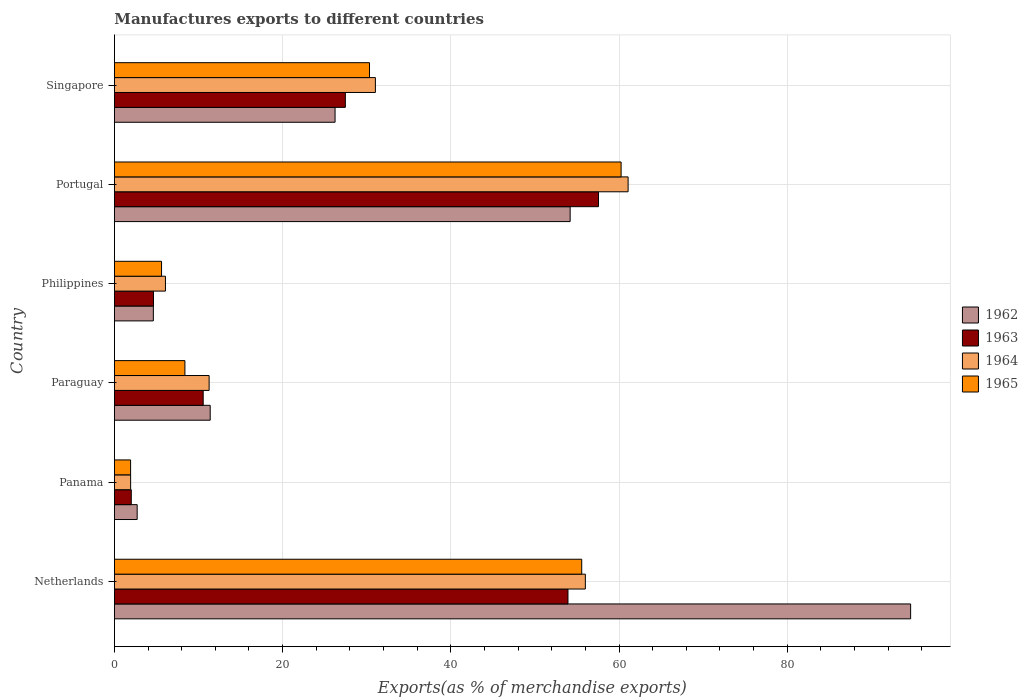Are the number of bars per tick equal to the number of legend labels?
Provide a short and direct response. Yes. How many bars are there on the 6th tick from the bottom?
Ensure brevity in your answer.  4. What is the label of the 6th group of bars from the top?
Keep it short and to the point. Netherlands. What is the percentage of exports to different countries in 1963 in Philippines?
Your answer should be compact. 4.64. Across all countries, what is the maximum percentage of exports to different countries in 1963?
Keep it short and to the point. 57.56. Across all countries, what is the minimum percentage of exports to different countries in 1963?
Your answer should be very brief. 2. In which country was the percentage of exports to different countries in 1964 maximum?
Your response must be concise. Portugal. In which country was the percentage of exports to different countries in 1963 minimum?
Keep it short and to the point. Panama. What is the total percentage of exports to different countries in 1962 in the graph?
Offer a very short reply. 193.83. What is the difference between the percentage of exports to different countries in 1962 in Panama and that in Singapore?
Your answer should be compact. -23.53. What is the difference between the percentage of exports to different countries in 1962 in Panama and the percentage of exports to different countries in 1963 in Singapore?
Make the answer very short. -24.76. What is the average percentage of exports to different countries in 1964 per country?
Keep it short and to the point. 27.89. What is the difference between the percentage of exports to different countries in 1962 and percentage of exports to different countries in 1963 in Paraguay?
Offer a terse response. 0.83. What is the ratio of the percentage of exports to different countries in 1962 in Netherlands to that in Paraguay?
Provide a short and direct response. 8.31. Is the percentage of exports to different countries in 1965 in Panama less than that in Portugal?
Give a very brief answer. Yes. What is the difference between the highest and the second highest percentage of exports to different countries in 1965?
Your response must be concise. 4.68. What is the difference between the highest and the lowest percentage of exports to different countries in 1963?
Make the answer very short. 55.56. What does the 3rd bar from the top in Philippines represents?
Ensure brevity in your answer.  1963. What does the 2nd bar from the bottom in Philippines represents?
Offer a very short reply. 1963. How many bars are there?
Offer a terse response. 24. Where does the legend appear in the graph?
Your answer should be compact. Center right. How many legend labels are there?
Offer a terse response. 4. How are the legend labels stacked?
Ensure brevity in your answer.  Vertical. What is the title of the graph?
Provide a succinct answer. Manufactures exports to different countries. What is the label or title of the X-axis?
Provide a short and direct response. Exports(as % of merchandise exports). What is the Exports(as % of merchandise exports) of 1962 in Netherlands?
Give a very brief answer. 94.68. What is the Exports(as % of merchandise exports) of 1963 in Netherlands?
Offer a very short reply. 53.93. What is the Exports(as % of merchandise exports) in 1964 in Netherlands?
Offer a terse response. 56. What is the Exports(as % of merchandise exports) of 1965 in Netherlands?
Ensure brevity in your answer.  55.57. What is the Exports(as % of merchandise exports) in 1962 in Panama?
Provide a succinct answer. 2.7. What is the Exports(as % of merchandise exports) in 1963 in Panama?
Make the answer very short. 2. What is the Exports(as % of merchandise exports) in 1964 in Panama?
Offer a very short reply. 1.93. What is the Exports(as % of merchandise exports) of 1965 in Panama?
Provide a short and direct response. 1.92. What is the Exports(as % of merchandise exports) in 1962 in Paraguay?
Keep it short and to the point. 11.39. What is the Exports(as % of merchandise exports) in 1963 in Paraguay?
Provide a succinct answer. 10.55. What is the Exports(as % of merchandise exports) in 1964 in Paraguay?
Give a very brief answer. 11.26. What is the Exports(as % of merchandise exports) of 1965 in Paraguay?
Your response must be concise. 8.38. What is the Exports(as % of merchandise exports) of 1962 in Philippines?
Offer a terse response. 4.63. What is the Exports(as % of merchandise exports) in 1963 in Philippines?
Provide a short and direct response. 4.64. What is the Exports(as % of merchandise exports) of 1964 in Philippines?
Offer a very short reply. 6.07. What is the Exports(as % of merchandise exports) in 1965 in Philippines?
Ensure brevity in your answer.  5.6. What is the Exports(as % of merchandise exports) in 1962 in Portugal?
Provide a short and direct response. 54.19. What is the Exports(as % of merchandise exports) of 1963 in Portugal?
Keep it short and to the point. 57.56. What is the Exports(as % of merchandise exports) in 1964 in Portugal?
Your answer should be very brief. 61.08. What is the Exports(as % of merchandise exports) of 1965 in Portugal?
Provide a short and direct response. 60.25. What is the Exports(as % of merchandise exports) in 1962 in Singapore?
Provide a short and direct response. 26.24. What is the Exports(as % of merchandise exports) of 1963 in Singapore?
Make the answer very short. 27.46. What is the Exports(as % of merchandise exports) in 1964 in Singapore?
Offer a very short reply. 31.03. What is the Exports(as % of merchandise exports) of 1965 in Singapore?
Give a very brief answer. 30.33. Across all countries, what is the maximum Exports(as % of merchandise exports) of 1962?
Your response must be concise. 94.68. Across all countries, what is the maximum Exports(as % of merchandise exports) of 1963?
Your response must be concise. 57.56. Across all countries, what is the maximum Exports(as % of merchandise exports) in 1964?
Your response must be concise. 61.08. Across all countries, what is the maximum Exports(as % of merchandise exports) in 1965?
Give a very brief answer. 60.25. Across all countries, what is the minimum Exports(as % of merchandise exports) in 1962?
Offer a terse response. 2.7. Across all countries, what is the minimum Exports(as % of merchandise exports) in 1963?
Keep it short and to the point. 2. Across all countries, what is the minimum Exports(as % of merchandise exports) of 1964?
Ensure brevity in your answer.  1.93. Across all countries, what is the minimum Exports(as % of merchandise exports) in 1965?
Ensure brevity in your answer.  1.92. What is the total Exports(as % of merchandise exports) in 1962 in the graph?
Your answer should be very brief. 193.83. What is the total Exports(as % of merchandise exports) of 1963 in the graph?
Ensure brevity in your answer.  156.16. What is the total Exports(as % of merchandise exports) of 1964 in the graph?
Provide a short and direct response. 167.37. What is the total Exports(as % of merchandise exports) of 1965 in the graph?
Provide a short and direct response. 162.06. What is the difference between the Exports(as % of merchandise exports) in 1962 in Netherlands and that in Panama?
Give a very brief answer. 91.97. What is the difference between the Exports(as % of merchandise exports) of 1963 in Netherlands and that in Panama?
Your answer should be very brief. 51.93. What is the difference between the Exports(as % of merchandise exports) of 1964 in Netherlands and that in Panama?
Offer a very short reply. 54.07. What is the difference between the Exports(as % of merchandise exports) of 1965 in Netherlands and that in Panama?
Your answer should be compact. 53.64. What is the difference between the Exports(as % of merchandise exports) in 1962 in Netherlands and that in Paraguay?
Your answer should be very brief. 83.29. What is the difference between the Exports(as % of merchandise exports) in 1963 in Netherlands and that in Paraguay?
Make the answer very short. 43.38. What is the difference between the Exports(as % of merchandise exports) of 1964 in Netherlands and that in Paraguay?
Your answer should be compact. 44.74. What is the difference between the Exports(as % of merchandise exports) in 1965 in Netherlands and that in Paraguay?
Provide a short and direct response. 47.19. What is the difference between the Exports(as % of merchandise exports) in 1962 in Netherlands and that in Philippines?
Your response must be concise. 90.05. What is the difference between the Exports(as % of merchandise exports) of 1963 in Netherlands and that in Philippines?
Make the answer very short. 49.29. What is the difference between the Exports(as % of merchandise exports) of 1964 in Netherlands and that in Philippines?
Your response must be concise. 49.93. What is the difference between the Exports(as % of merchandise exports) in 1965 in Netherlands and that in Philippines?
Offer a very short reply. 49.96. What is the difference between the Exports(as % of merchandise exports) in 1962 in Netherlands and that in Portugal?
Your answer should be very brief. 40.48. What is the difference between the Exports(as % of merchandise exports) in 1963 in Netherlands and that in Portugal?
Your response must be concise. -3.63. What is the difference between the Exports(as % of merchandise exports) in 1964 in Netherlands and that in Portugal?
Your response must be concise. -5.08. What is the difference between the Exports(as % of merchandise exports) of 1965 in Netherlands and that in Portugal?
Offer a very short reply. -4.68. What is the difference between the Exports(as % of merchandise exports) of 1962 in Netherlands and that in Singapore?
Your answer should be compact. 68.44. What is the difference between the Exports(as % of merchandise exports) in 1963 in Netherlands and that in Singapore?
Your response must be concise. 26.47. What is the difference between the Exports(as % of merchandise exports) in 1964 in Netherlands and that in Singapore?
Offer a very short reply. 24.97. What is the difference between the Exports(as % of merchandise exports) in 1965 in Netherlands and that in Singapore?
Your answer should be compact. 25.23. What is the difference between the Exports(as % of merchandise exports) in 1962 in Panama and that in Paraguay?
Your answer should be very brief. -8.69. What is the difference between the Exports(as % of merchandise exports) of 1963 in Panama and that in Paraguay?
Provide a succinct answer. -8.55. What is the difference between the Exports(as % of merchandise exports) in 1964 in Panama and that in Paraguay?
Keep it short and to the point. -9.33. What is the difference between the Exports(as % of merchandise exports) in 1965 in Panama and that in Paraguay?
Your answer should be very brief. -6.46. What is the difference between the Exports(as % of merchandise exports) of 1962 in Panama and that in Philippines?
Your response must be concise. -1.92. What is the difference between the Exports(as % of merchandise exports) in 1963 in Panama and that in Philippines?
Your answer should be very brief. -2.64. What is the difference between the Exports(as % of merchandise exports) in 1964 in Panama and that in Philippines?
Provide a succinct answer. -4.14. What is the difference between the Exports(as % of merchandise exports) in 1965 in Panama and that in Philippines?
Your answer should be compact. -3.68. What is the difference between the Exports(as % of merchandise exports) of 1962 in Panama and that in Portugal?
Keep it short and to the point. -51.49. What is the difference between the Exports(as % of merchandise exports) of 1963 in Panama and that in Portugal?
Give a very brief answer. -55.56. What is the difference between the Exports(as % of merchandise exports) of 1964 in Panama and that in Portugal?
Give a very brief answer. -59.16. What is the difference between the Exports(as % of merchandise exports) of 1965 in Panama and that in Portugal?
Your answer should be very brief. -58.33. What is the difference between the Exports(as % of merchandise exports) in 1962 in Panama and that in Singapore?
Your answer should be very brief. -23.53. What is the difference between the Exports(as % of merchandise exports) of 1963 in Panama and that in Singapore?
Your answer should be very brief. -25.46. What is the difference between the Exports(as % of merchandise exports) of 1964 in Panama and that in Singapore?
Provide a short and direct response. -29.1. What is the difference between the Exports(as % of merchandise exports) in 1965 in Panama and that in Singapore?
Give a very brief answer. -28.41. What is the difference between the Exports(as % of merchandise exports) of 1962 in Paraguay and that in Philippines?
Offer a very short reply. 6.76. What is the difference between the Exports(as % of merchandise exports) in 1963 in Paraguay and that in Philippines?
Your answer should be compact. 5.91. What is the difference between the Exports(as % of merchandise exports) of 1964 in Paraguay and that in Philippines?
Provide a short and direct response. 5.19. What is the difference between the Exports(as % of merchandise exports) of 1965 in Paraguay and that in Philippines?
Provide a succinct answer. 2.78. What is the difference between the Exports(as % of merchandise exports) of 1962 in Paraguay and that in Portugal?
Offer a very short reply. -42.8. What is the difference between the Exports(as % of merchandise exports) of 1963 in Paraguay and that in Portugal?
Give a very brief answer. -47.01. What is the difference between the Exports(as % of merchandise exports) in 1964 in Paraguay and that in Portugal?
Offer a very short reply. -49.82. What is the difference between the Exports(as % of merchandise exports) of 1965 in Paraguay and that in Portugal?
Keep it short and to the point. -51.87. What is the difference between the Exports(as % of merchandise exports) in 1962 in Paraguay and that in Singapore?
Keep it short and to the point. -14.85. What is the difference between the Exports(as % of merchandise exports) of 1963 in Paraguay and that in Singapore?
Keep it short and to the point. -16.91. What is the difference between the Exports(as % of merchandise exports) in 1964 in Paraguay and that in Singapore?
Your answer should be very brief. -19.77. What is the difference between the Exports(as % of merchandise exports) in 1965 in Paraguay and that in Singapore?
Make the answer very short. -21.95. What is the difference between the Exports(as % of merchandise exports) of 1962 in Philippines and that in Portugal?
Give a very brief answer. -49.57. What is the difference between the Exports(as % of merchandise exports) in 1963 in Philippines and that in Portugal?
Make the answer very short. -52.92. What is the difference between the Exports(as % of merchandise exports) in 1964 in Philippines and that in Portugal?
Your answer should be compact. -55.02. What is the difference between the Exports(as % of merchandise exports) in 1965 in Philippines and that in Portugal?
Provide a short and direct response. -54.65. What is the difference between the Exports(as % of merchandise exports) of 1962 in Philippines and that in Singapore?
Keep it short and to the point. -21.61. What is the difference between the Exports(as % of merchandise exports) in 1963 in Philippines and that in Singapore?
Provide a short and direct response. -22.82. What is the difference between the Exports(as % of merchandise exports) in 1964 in Philippines and that in Singapore?
Your answer should be very brief. -24.96. What is the difference between the Exports(as % of merchandise exports) of 1965 in Philippines and that in Singapore?
Ensure brevity in your answer.  -24.73. What is the difference between the Exports(as % of merchandise exports) of 1962 in Portugal and that in Singapore?
Your response must be concise. 27.96. What is the difference between the Exports(as % of merchandise exports) in 1963 in Portugal and that in Singapore?
Your answer should be very brief. 30.1. What is the difference between the Exports(as % of merchandise exports) of 1964 in Portugal and that in Singapore?
Ensure brevity in your answer.  30.05. What is the difference between the Exports(as % of merchandise exports) in 1965 in Portugal and that in Singapore?
Provide a short and direct response. 29.92. What is the difference between the Exports(as % of merchandise exports) of 1962 in Netherlands and the Exports(as % of merchandise exports) of 1963 in Panama?
Your response must be concise. 92.67. What is the difference between the Exports(as % of merchandise exports) in 1962 in Netherlands and the Exports(as % of merchandise exports) in 1964 in Panama?
Keep it short and to the point. 92.75. What is the difference between the Exports(as % of merchandise exports) in 1962 in Netherlands and the Exports(as % of merchandise exports) in 1965 in Panama?
Your answer should be very brief. 92.75. What is the difference between the Exports(as % of merchandise exports) of 1963 in Netherlands and the Exports(as % of merchandise exports) of 1964 in Panama?
Your response must be concise. 52. What is the difference between the Exports(as % of merchandise exports) in 1963 in Netherlands and the Exports(as % of merchandise exports) in 1965 in Panama?
Offer a very short reply. 52.01. What is the difference between the Exports(as % of merchandise exports) of 1964 in Netherlands and the Exports(as % of merchandise exports) of 1965 in Panama?
Your answer should be compact. 54.07. What is the difference between the Exports(as % of merchandise exports) of 1962 in Netherlands and the Exports(as % of merchandise exports) of 1963 in Paraguay?
Ensure brevity in your answer.  84.12. What is the difference between the Exports(as % of merchandise exports) in 1962 in Netherlands and the Exports(as % of merchandise exports) in 1964 in Paraguay?
Provide a succinct answer. 83.42. What is the difference between the Exports(as % of merchandise exports) of 1962 in Netherlands and the Exports(as % of merchandise exports) of 1965 in Paraguay?
Provide a succinct answer. 86.3. What is the difference between the Exports(as % of merchandise exports) of 1963 in Netherlands and the Exports(as % of merchandise exports) of 1964 in Paraguay?
Offer a terse response. 42.67. What is the difference between the Exports(as % of merchandise exports) in 1963 in Netherlands and the Exports(as % of merchandise exports) in 1965 in Paraguay?
Offer a terse response. 45.55. What is the difference between the Exports(as % of merchandise exports) of 1964 in Netherlands and the Exports(as % of merchandise exports) of 1965 in Paraguay?
Ensure brevity in your answer.  47.62. What is the difference between the Exports(as % of merchandise exports) in 1962 in Netherlands and the Exports(as % of merchandise exports) in 1963 in Philippines?
Keep it short and to the point. 90.03. What is the difference between the Exports(as % of merchandise exports) of 1962 in Netherlands and the Exports(as % of merchandise exports) of 1964 in Philippines?
Your response must be concise. 88.61. What is the difference between the Exports(as % of merchandise exports) of 1962 in Netherlands and the Exports(as % of merchandise exports) of 1965 in Philippines?
Provide a succinct answer. 89.07. What is the difference between the Exports(as % of merchandise exports) in 1963 in Netherlands and the Exports(as % of merchandise exports) in 1964 in Philippines?
Provide a succinct answer. 47.86. What is the difference between the Exports(as % of merchandise exports) in 1963 in Netherlands and the Exports(as % of merchandise exports) in 1965 in Philippines?
Ensure brevity in your answer.  48.33. What is the difference between the Exports(as % of merchandise exports) of 1964 in Netherlands and the Exports(as % of merchandise exports) of 1965 in Philippines?
Offer a very short reply. 50.4. What is the difference between the Exports(as % of merchandise exports) of 1962 in Netherlands and the Exports(as % of merchandise exports) of 1963 in Portugal?
Ensure brevity in your answer.  37.12. What is the difference between the Exports(as % of merchandise exports) of 1962 in Netherlands and the Exports(as % of merchandise exports) of 1964 in Portugal?
Offer a terse response. 33.59. What is the difference between the Exports(as % of merchandise exports) of 1962 in Netherlands and the Exports(as % of merchandise exports) of 1965 in Portugal?
Offer a very short reply. 34.43. What is the difference between the Exports(as % of merchandise exports) of 1963 in Netherlands and the Exports(as % of merchandise exports) of 1964 in Portugal?
Offer a very short reply. -7.15. What is the difference between the Exports(as % of merchandise exports) of 1963 in Netherlands and the Exports(as % of merchandise exports) of 1965 in Portugal?
Make the answer very short. -6.32. What is the difference between the Exports(as % of merchandise exports) in 1964 in Netherlands and the Exports(as % of merchandise exports) in 1965 in Portugal?
Make the answer very short. -4.25. What is the difference between the Exports(as % of merchandise exports) in 1962 in Netherlands and the Exports(as % of merchandise exports) in 1963 in Singapore?
Your response must be concise. 67.22. What is the difference between the Exports(as % of merchandise exports) in 1962 in Netherlands and the Exports(as % of merchandise exports) in 1964 in Singapore?
Your response must be concise. 63.65. What is the difference between the Exports(as % of merchandise exports) of 1962 in Netherlands and the Exports(as % of merchandise exports) of 1965 in Singapore?
Offer a very short reply. 64.34. What is the difference between the Exports(as % of merchandise exports) in 1963 in Netherlands and the Exports(as % of merchandise exports) in 1964 in Singapore?
Your answer should be compact. 22.9. What is the difference between the Exports(as % of merchandise exports) of 1963 in Netherlands and the Exports(as % of merchandise exports) of 1965 in Singapore?
Give a very brief answer. 23.6. What is the difference between the Exports(as % of merchandise exports) of 1964 in Netherlands and the Exports(as % of merchandise exports) of 1965 in Singapore?
Your answer should be very brief. 25.67. What is the difference between the Exports(as % of merchandise exports) of 1962 in Panama and the Exports(as % of merchandise exports) of 1963 in Paraguay?
Provide a short and direct response. -7.85. What is the difference between the Exports(as % of merchandise exports) in 1962 in Panama and the Exports(as % of merchandise exports) in 1964 in Paraguay?
Your answer should be compact. -8.56. What is the difference between the Exports(as % of merchandise exports) in 1962 in Panama and the Exports(as % of merchandise exports) in 1965 in Paraguay?
Your answer should be very brief. -5.68. What is the difference between the Exports(as % of merchandise exports) of 1963 in Panama and the Exports(as % of merchandise exports) of 1964 in Paraguay?
Provide a short and direct response. -9.26. What is the difference between the Exports(as % of merchandise exports) in 1963 in Panama and the Exports(as % of merchandise exports) in 1965 in Paraguay?
Keep it short and to the point. -6.38. What is the difference between the Exports(as % of merchandise exports) in 1964 in Panama and the Exports(as % of merchandise exports) in 1965 in Paraguay?
Keep it short and to the point. -6.45. What is the difference between the Exports(as % of merchandise exports) of 1962 in Panama and the Exports(as % of merchandise exports) of 1963 in Philippines?
Offer a terse response. -1.94. What is the difference between the Exports(as % of merchandise exports) of 1962 in Panama and the Exports(as % of merchandise exports) of 1964 in Philippines?
Give a very brief answer. -3.36. What is the difference between the Exports(as % of merchandise exports) of 1962 in Panama and the Exports(as % of merchandise exports) of 1965 in Philippines?
Offer a very short reply. -2.9. What is the difference between the Exports(as % of merchandise exports) in 1963 in Panama and the Exports(as % of merchandise exports) in 1964 in Philippines?
Your answer should be very brief. -4.06. What is the difference between the Exports(as % of merchandise exports) in 1963 in Panama and the Exports(as % of merchandise exports) in 1965 in Philippines?
Your answer should be compact. -3.6. What is the difference between the Exports(as % of merchandise exports) of 1964 in Panama and the Exports(as % of merchandise exports) of 1965 in Philippines?
Your answer should be compact. -3.68. What is the difference between the Exports(as % of merchandise exports) in 1962 in Panama and the Exports(as % of merchandise exports) in 1963 in Portugal?
Provide a short and direct response. -54.86. What is the difference between the Exports(as % of merchandise exports) of 1962 in Panama and the Exports(as % of merchandise exports) of 1964 in Portugal?
Offer a very short reply. -58.38. What is the difference between the Exports(as % of merchandise exports) in 1962 in Panama and the Exports(as % of merchandise exports) in 1965 in Portugal?
Offer a terse response. -57.55. What is the difference between the Exports(as % of merchandise exports) of 1963 in Panama and the Exports(as % of merchandise exports) of 1964 in Portugal?
Your response must be concise. -59.08. What is the difference between the Exports(as % of merchandise exports) of 1963 in Panama and the Exports(as % of merchandise exports) of 1965 in Portugal?
Give a very brief answer. -58.25. What is the difference between the Exports(as % of merchandise exports) of 1964 in Panama and the Exports(as % of merchandise exports) of 1965 in Portugal?
Give a very brief answer. -58.32. What is the difference between the Exports(as % of merchandise exports) of 1962 in Panama and the Exports(as % of merchandise exports) of 1963 in Singapore?
Make the answer very short. -24.76. What is the difference between the Exports(as % of merchandise exports) of 1962 in Panama and the Exports(as % of merchandise exports) of 1964 in Singapore?
Make the answer very short. -28.33. What is the difference between the Exports(as % of merchandise exports) of 1962 in Panama and the Exports(as % of merchandise exports) of 1965 in Singapore?
Keep it short and to the point. -27.63. What is the difference between the Exports(as % of merchandise exports) in 1963 in Panama and the Exports(as % of merchandise exports) in 1964 in Singapore?
Provide a short and direct response. -29.03. What is the difference between the Exports(as % of merchandise exports) in 1963 in Panama and the Exports(as % of merchandise exports) in 1965 in Singapore?
Your answer should be compact. -28.33. What is the difference between the Exports(as % of merchandise exports) in 1964 in Panama and the Exports(as % of merchandise exports) in 1965 in Singapore?
Provide a succinct answer. -28.41. What is the difference between the Exports(as % of merchandise exports) in 1962 in Paraguay and the Exports(as % of merchandise exports) in 1963 in Philippines?
Provide a succinct answer. 6.75. What is the difference between the Exports(as % of merchandise exports) in 1962 in Paraguay and the Exports(as % of merchandise exports) in 1964 in Philippines?
Ensure brevity in your answer.  5.32. What is the difference between the Exports(as % of merchandise exports) of 1962 in Paraguay and the Exports(as % of merchandise exports) of 1965 in Philippines?
Your answer should be compact. 5.79. What is the difference between the Exports(as % of merchandise exports) of 1963 in Paraguay and the Exports(as % of merchandise exports) of 1964 in Philippines?
Give a very brief answer. 4.49. What is the difference between the Exports(as % of merchandise exports) of 1963 in Paraguay and the Exports(as % of merchandise exports) of 1965 in Philippines?
Provide a succinct answer. 4.95. What is the difference between the Exports(as % of merchandise exports) of 1964 in Paraguay and the Exports(as % of merchandise exports) of 1965 in Philippines?
Your response must be concise. 5.66. What is the difference between the Exports(as % of merchandise exports) in 1962 in Paraguay and the Exports(as % of merchandise exports) in 1963 in Portugal?
Ensure brevity in your answer.  -46.17. What is the difference between the Exports(as % of merchandise exports) in 1962 in Paraguay and the Exports(as % of merchandise exports) in 1964 in Portugal?
Offer a very short reply. -49.69. What is the difference between the Exports(as % of merchandise exports) of 1962 in Paraguay and the Exports(as % of merchandise exports) of 1965 in Portugal?
Keep it short and to the point. -48.86. What is the difference between the Exports(as % of merchandise exports) in 1963 in Paraguay and the Exports(as % of merchandise exports) in 1964 in Portugal?
Your answer should be very brief. -50.53. What is the difference between the Exports(as % of merchandise exports) in 1963 in Paraguay and the Exports(as % of merchandise exports) in 1965 in Portugal?
Give a very brief answer. -49.7. What is the difference between the Exports(as % of merchandise exports) of 1964 in Paraguay and the Exports(as % of merchandise exports) of 1965 in Portugal?
Give a very brief answer. -48.99. What is the difference between the Exports(as % of merchandise exports) of 1962 in Paraguay and the Exports(as % of merchandise exports) of 1963 in Singapore?
Your answer should be very brief. -16.07. What is the difference between the Exports(as % of merchandise exports) of 1962 in Paraguay and the Exports(as % of merchandise exports) of 1964 in Singapore?
Offer a very short reply. -19.64. What is the difference between the Exports(as % of merchandise exports) of 1962 in Paraguay and the Exports(as % of merchandise exports) of 1965 in Singapore?
Offer a terse response. -18.94. What is the difference between the Exports(as % of merchandise exports) of 1963 in Paraguay and the Exports(as % of merchandise exports) of 1964 in Singapore?
Make the answer very short. -20.48. What is the difference between the Exports(as % of merchandise exports) of 1963 in Paraguay and the Exports(as % of merchandise exports) of 1965 in Singapore?
Offer a terse response. -19.78. What is the difference between the Exports(as % of merchandise exports) of 1964 in Paraguay and the Exports(as % of merchandise exports) of 1965 in Singapore?
Make the answer very short. -19.07. What is the difference between the Exports(as % of merchandise exports) in 1962 in Philippines and the Exports(as % of merchandise exports) in 1963 in Portugal?
Provide a succinct answer. -52.93. What is the difference between the Exports(as % of merchandise exports) of 1962 in Philippines and the Exports(as % of merchandise exports) of 1964 in Portugal?
Your answer should be compact. -56.46. What is the difference between the Exports(as % of merchandise exports) of 1962 in Philippines and the Exports(as % of merchandise exports) of 1965 in Portugal?
Your response must be concise. -55.62. What is the difference between the Exports(as % of merchandise exports) of 1963 in Philippines and the Exports(as % of merchandise exports) of 1964 in Portugal?
Give a very brief answer. -56.44. What is the difference between the Exports(as % of merchandise exports) of 1963 in Philippines and the Exports(as % of merchandise exports) of 1965 in Portugal?
Give a very brief answer. -55.61. What is the difference between the Exports(as % of merchandise exports) of 1964 in Philippines and the Exports(as % of merchandise exports) of 1965 in Portugal?
Provide a short and direct response. -54.18. What is the difference between the Exports(as % of merchandise exports) of 1962 in Philippines and the Exports(as % of merchandise exports) of 1963 in Singapore?
Keep it short and to the point. -22.83. What is the difference between the Exports(as % of merchandise exports) of 1962 in Philippines and the Exports(as % of merchandise exports) of 1964 in Singapore?
Your answer should be very brief. -26.4. What is the difference between the Exports(as % of merchandise exports) in 1962 in Philippines and the Exports(as % of merchandise exports) in 1965 in Singapore?
Keep it short and to the point. -25.7. What is the difference between the Exports(as % of merchandise exports) in 1963 in Philippines and the Exports(as % of merchandise exports) in 1964 in Singapore?
Keep it short and to the point. -26.39. What is the difference between the Exports(as % of merchandise exports) in 1963 in Philippines and the Exports(as % of merchandise exports) in 1965 in Singapore?
Provide a succinct answer. -25.69. What is the difference between the Exports(as % of merchandise exports) of 1964 in Philippines and the Exports(as % of merchandise exports) of 1965 in Singapore?
Offer a very short reply. -24.27. What is the difference between the Exports(as % of merchandise exports) of 1962 in Portugal and the Exports(as % of merchandise exports) of 1963 in Singapore?
Offer a terse response. 26.73. What is the difference between the Exports(as % of merchandise exports) in 1962 in Portugal and the Exports(as % of merchandise exports) in 1964 in Singapore?
Your response must be concise. 23.16. What is the difference between the Exports(as % of merchandise exports) in 1962 in Portugal and the Exports(as % of merchandise exports) in 1965 in Singapore?
Keep it short and to the point. 23.86. What is the difference between the Exports(as % of merchandise exports) of 1963 in Portugal and the Exports(as % of merchandise exports) of 1964 in Singapore?
Ensure brevity in your answer.  26.53. What is the difference between the Exports(as % of merchandise exports) in 1963 in Portugal and the Exports(as % of merchandise exports) in 1965 in Singapore?
Offer a very short reply. 27.23. What is the difference between the Exports(as % of merchandise exports) of 1964 in Portugal and the Exports(as % of merchandise exports) of 1965 in Singapore?
Your answer should be compact. 30.75. What is the average Exports(as % of merchandise exports) of 1962 per country?
Keep it short and to the point. 32.3. What is the average Exports(as % of merchandise exports) of 1963 per country?
Provide a succinct answer. 26.03. What is the average Exports(as % of merchandise exports) in 1964 per country?
Your answer should be very brief. 27.89. What is the average Exports(as % of merchandise exports) in 1965 per country?
Provide a succinct answer. 27.01. What is the difference between the Exports(as % of merchandise exports) in 1962 and Exports(as % of merchandise exports) in 1963 in Netherlands?
Your answer should be compact. 40.75. What is the difference between the Exports(as % of merchandise exports) of 1962 and Exports(as % of merchandise exports) of 1964 in Netherlands?
Offer a terse response. 38.68. What is the difference between the Exports(as % of merchandise exports) in 1962 and Exports(as % of merchandise exports) in 1965 in Netherlands?
Your response must be concise. 39.11. What is the difference between the Exports(as % of merchandise exports) in 1963 and Exports(as % of merchandise exports) in 1964 in Netherlands?
Ensure brevity in your answer.  -2.07. What is the difference between the Exports(as % of merchandise exports) of 1963 and Exports(as % of merchandise exports) of 1965 in Netherlands?
Make the answer very short. -1.64. What is the difference between the Exports(as % of merchandise exports) of 1964 and Exports(as % of merchandise exports) of 1965 in Netherlands?
Provide a succinct answer. 0.43. What is the difference between the Exports(as % of merchandise exports) of 1962 and Exports(as % of merchandise exports) of 1963 in Panama?
Your answer should be very brief. 0.7. What is the difference between the Exports(as % of merchandise exports) in 1962 and Exports(as % of merchandise exports) in 1964 in Panama?
Your answer should be very brief. 0.78. What is the difference between the Exports(as % of merchandise exports) in 1962 and Exports(as % of merchandise exports) in 1965 in Panama?
Offer a terse response. 0.78. What is the difference between the Exports(as % of merchandise exports) in 1963 and Exports(as % of merchandise exports) in 1964 in Panama?
Provide a succinct answer. 0.08. What is the difference between the Exports(as % of merchandise exports) in 1963 and Exports(as % of merchandise exports) in 1965 in Panama?
Provide a succinct answer. 0.08. What is the difference between the Exports(as % of merchandise exports) of 1964 and Exports(as % of merchandise exports) of 1965 in Panama?
Ensure brevity in your answer.  0. What is the difference between the Exports(as % of merchandise exports) in 1962 and Exports(as % of merchandise exports) in 1963 in Paraguay?
Make the answer very short. 0.83. What is the difference between the Exports(as % of merchandise exports) in 1962 and Exports(as % of merchandise exports) in 1964 in Paraguay?
Offer a terse response. 0.13. What is the difference between the Exports(as % of merchandise exports) of 1962 and Exports(as % of merchandise exports) of 1965 in Paraguay?
Provide a short and direct response. 3.01. What is the difference between the Exports(as % of merchandise exports) of 1963 and Exports(as % of merchandise exports) of 1964 in Paraguay?
Your answer should be very brief. -0.71. What is the difference between the Exports(as % of merchandise exports) of 1963 and Exports(as % of merchandise exports) of 1965 in Paraguay?
Ensure brevity in your answer.  2.17. What is the difference between the Exports(as % of merchandise exports) in 1964 and Exports(as % of merchandise exports) in 1965 in Paraguay?
Offer a terse response. 2.88. What is the difference between the Exports(as % of merchandise exports) of 1962 and Exports(as % of merchandise exports) of 1963 in Philippines?
Your answer should be very brief. -0.02. What is the difference between the Exports(as % of merchandise exports) of 1962 and Exports(as % of merchandise exports) of 1964 in Philippines?
Offer a very short reply. -1.44. What is the difference between the Exports(as % of merchandise exports) in 1962 and Exports(as % of merchandise exports) in 1965 in Philippines?
Your response must be concise. -0.98. What is the difference between the Exports(as % of merchandise exports) of 1963 and Exports(as % of merchandise exports) of 1964 in Philippines?
Provide a succinct answer. -1.42. What is the difference between the Exports(as % of merchandise exports) of 1963 and Exports(as % of merchandise exports) of 1965 in Philippines?
Offer a very short reply. -0.96. What is the difference between the Exports(as % of merchandise exports) in 1964 and Exports(as % of merchandise exports) in 1965 in Philippines?
Provide a short and direct response. 0.46. What is the difference between the Exports(as % of merchandise exports) of 1962 and Exports(as % of merchandise exports) of 1963 in Portugal?
Your answer should be very brief. -3.37. What is the difference between the Exports(as % of merchandise exports) of 1962 and Exports(as % of merchandise exports) of 1964 in Portugal?
Ensure brevity in your answer.  -6.89. What is the difference between the Exports(as % of merchandise exports) of 1962 and Exports(as % of merchandise exports) of 1965 in Portugal?
Make the answer very short. -6.06. What is the difference between the Exports(as % of merchandise exports) of 1963 and Exports(as % of merchandise exports) of 1964 in Portugal?
Offer a very short reply. -3.52. What is the difference between the Exports(as % of merchandise exports) in 1963 and Exports(as % of merchandise exports) in 1965 in Portugal?
Provide a succinct answer. -2.69. What is the difference between the Exports(as % of merchandise exports) of 1964 and Exports(as % of merchandise exports) of 1965 in Portugal?
Give a very brief answer. 0.83. What is the difference between the Exports(as % of merchandise exports) of 1962 and Exports(as % of merchandise exports) of 1963 in Singapore?
Give a very brief answer. -1.22. What is the difference between the Exports(as % of merchandise exports) of 1962 and Exports(as % of merchandise exports) of 1964 in Singapore?
Offer a terse response. -4.79. What is the difference between the Exports(as % of merchandise exports) in 1962 and Exports(as % of merchandise exports) in 1965 in Singapore?
Provide a short and direct response. -4.1. What is the difference between the Exports(as % of merchandise exports) in 1963 and Exports(as % of merchandise exports) in 1964 in Singapore?
Your answer should be very brief. -3.57. What is the difference between the Exports(as % of merchandise exports) of 1963 and Exports(as % of merchandise exports) of 1965 in Singapore?
Your response must be concise. -2.87. What is the difference between the Exports(as % of merchandise exports) in 1964 and Exports(as % of merchandise exports) in 1965 in Singapore?
Offer a terse response. 0.7. What is the ratio of the Exports(as % of merchandise exports) of 1962 in Netherlands to that in Panama?
Keep it short and to the point. 35.02. What is the ratio of the Exports(as % of merchandise exports) in 1963 in Netherlands to that in Panama?
Keep it short and to the point. 26.91. What is the ratio of the Exports(as % of merchandise exports) in 1964 in Netherlands to that in Panama?
Your answer should be compact. 29.06. What is the ratio of the Exports(as % of merchandise exports) in 1965 in Netherlands to that in Panama?
Keep it short and to the point. 28.9. What is the ratio of the Exports(as % of merchandise exports) in 1962 in Netherlands to that in Paraguay?
Give a very brief answer. 8.31. What is the ratio of the Exports(as % of merchandise exports) in 1963 in Netherlands to that in Paraguay?
Give a very brief answer. 5.11. What is the ratio of the Exports(as % of merchandise exports) of 1964 in Netherlands to that in Paraguay?
Give a very brief answer. 4.97. What is the ratio of the Exports(as % of merchandise exports) in 1965 in Netherlands to that in Paraguay?
Give a very brief answer. 6.63. What is the ratio of the Exports(as % of merchandise exports) of 1962 in Netherlands to that in Philippines?
Your response must be concise. 20.46. What is the ratio of the Exports(as % of merchandise exports) of 1963 in Netherlands to that in Philippines?
Offer a very short reply. 11.61. What is the ratio of the Exports(as % of merchandise exports) of 1964 in Netherlands to that in Philippines?
Provide a succinct answer. 9.23. What is the ratio of the Exports(as % of merchandise exports) of 1965 in Netherlands to that in Philippines?
Ensure brevity in your answer.  9.92. What is the ratio of the Exports(as % of merchandise exports) of 1962 in Netherlands to that in Portugal?
Make the answer very short. 1.75. What is the ratio of the Exports(as % of merchandise exports) of 1963 in Netherlands to that in Portugal?
Make the answer very short. 0.94. What is the ratio of the Exports(as % of merchandise exports) in 1964 in Netherlands to that in Portugal?
Your answer should be compact. 0.92. What is the ratio of the Exports(as % of merchandise exports) in 1965 in Netherlands to that in Portugal?
Give a very brief answer. 0.92. What is the ratio of the Exports(as % of merchandise exports) in 1962 in Netherlands to that in Singapore?
Your response must be concise. 3.61. What is the ratio of the Exports(as % of merchandise exports) in 1963 in Netherlands to that in Singapore?
Your response must be concise. 1.96. What is the ratio of the Exports(as % of merchandise exports) in 1964 in Netherlands to that in Singapore?
Ensure brevity in your answer.  1.8. What is the ratio of the Exports(as % of merchandise exports) of 1965 in Netherlands to that in Singapore?
Offer a very short reply. 1.83. What is the ratio of the Exports(as % of merchandise exports) in 1962 in Panama to that in Paraguay?
Provide a succinct answer. 0.24. What is the ratio of the Exports(as % of merchandise exports) of 1963 in Panama to that in Paraguay?
Make the answer very short. 0.19. What is the ratio of the Exports(as % of merchandise exports) in 1964 in Panama to that in Paraguay?
Your answer should be very brief. 0.17. What is the ratio of the Exports(as % of merchandise exports) of 1965 in Panama to that in Paraguay?
Give a very brief answer. 0.23. What is the ratio of the Exports(as % of merchandise exports) of 1962 in Panama to that in Philippines?
Provide a succinct answer. 0.58. What is the ratio of the Exports(as % of merchandise exports) of 1963 in Panama to that in Philippines?
Ensure brevity in your answer.  0.43. What is the ratio of the Exports(as % of merchandise exports) in 1964 in Panama to that in Philippines?
Provide a succinct answer. 0.32. What is the ratio of the Exports(as % of merchandise exports) of 1965 in Panama to that in Philippines?
Provide a short and direct response. 0.34. What is the ratio of the Exports(as % of merchandise exports) in 1962 in Panama to that in Portugal?
Provide a short and direct response. 0.05. What is the ratio of the Exports(as % of merchandise exports) of 1963 in Panama to that in Portugal?
Give a very brief answer. 0.03. What is the ratio of the Exports(as % of merchandise exports) in 1964 in Panama to that in Portugal?
Ensure brevity in your answer.  0.03. What is the ratio of the Exports(as % of merchandise exports) in 1965 in Panama to that in Portugal?
Your answer should be compact. 0.03. What is the ratio of the Exports(as % of merchandise exports) of 1962 in Panama to that in Singapore?
Provide a succinct answer. 0.1. What is the ratio of the Exports(as % of merchandise exports) in 1963 in Panama to that in Singapore?
Give a very brief answer. 0.07. What is the ratio of the Exports(as % of merchandise exports) of 1964 in Panama to that in Singapore?
Your answer should be very brief. 0.06. What is the ratio of the Exports(as % of merchandise exports) in 1965 in Panama to that in Singapore?
Make the answer very short. 0.06. What is the ratio of the Exports(as % of merchandise exports) in 1962 in Paraguay to that in Philippines?
Your answer should be compact. 2.46. What is the ratio of the Exports(as % of merchandise exports) in 1963 in Paraguay to that in Philippines?
Keep it short and to the point. 2.27. What is the ratio of the Exports(as % of merchandise exports) of 1964 in Paraguay to that in Philippines?
Keep it short and to the point. 1.86. What is the ratio of the Exports(as % of merchandise exports) of 1965 in Paraguay to that in Philippines?
Give a very brief answer. 1.5. What is the ratio of the Exports(as % of merchandise exports) of 1962 in Paraguay to that in Portugal?
Provide a short and direct response. 0.21. What is the ratio of the Exports(as % of merchandise exports) of 1963 in Paraguay to that in Portugal?
Offer a very short reply. 0.18. What is the ratio of the Exports(as % of merchandise exports) of 1964 in Paraguay to that in Portugal?
Ensure brevity in your answer.  0.18. What is the ratio of the Exports(as % of merchandise exports) in 1965 in Paraguay to that in Portugal?
Your answer should be compact. 0.14. What is the ratio of the Exports(as % of merchandise exports) of 1962 in Paraguay to that in Singapore?
Make the answer very short. 0.43. What is the ratio of the Exports(as % of merchandise exports) in 1963 in Paraguay to that in Singapore?
Your response must be concise. 0.38. What is the ratio of the Exports(as % of merchandise exports) in 1964 in Paraguay to that in Singapore?
Keep it short and to the point. 0.36. What is the ratio of the Exports(as % of merchandise exports) of 1965 in Paraguay to that in Singapore?
Ensure brevity in your answer.  0.28. What is the ratio of the Exports(as % of merchandise exports) of 1962 in Philippines to that in Portugal?
Give a very brief answer. 0.09. What is the ratio of the Exports(as % of merchandise exports) in 1963 in Philippines to that in Portugal?
Provide a succinct answer. 0.08. What is the ratio of the Exports(as % of merchandise exports) in 1964 in Philippines to that in Portugal?
Give a very brief answer. 0.1. What is the ratio of the Exports(as % of merchandise exports) in 1965 in Philippines to that in Portugal?
Your response must be concise. 0.09. What is the ratio of the Exports(as % of merchandise exports) in 1962 in Philippines to that in Singapore?
Offer a terse response. 0.18. What is the ratio of the Exports(as % of merchandise exports) of 1963 in Philippines to that in Singapore?
Keep it short and to the point. 0.17. What is the ratio of the Exports(as % of merchandise exports) of 1964 in Philippines to that in Singapore?
Make the answer very short. 0.2. What is the ratio of the Exports(as % of merchandise exports) of 1965 in Philippines to that in Singapore?
Keep it short and to the point. 0.18. What is the ratio of the Exports(as % of merchandise exports) of 1962 in Portugal to that in Singapore?
Make the answer very short. 2.07. What is the ratio of the Exports(as % of merchandise exports) of 1963 in Portugal to that in Singapore?
Provide a short and direct response. 2.1. What is the ratio of the Exports(as % of merchandise exports) in 1964 in Portugal to that in Singapore?
Offer a terse response. 1.97. What is the ratio of the Exports(as % of merchandise exports) of 1965 in Portugal to that in Singapore?
Your response must be concise. 1.99. What is the difference between the highest and the second highest Exports(as % of merchandise exports) of 1962?
Make the answer very short. 40.48. What is the difference between the highest and the second highest Exports(as % of merchandise exports) of 1963?
Your answer should be very brief. 3.63. What is the difference between the highest and the second highest Exports(as % of merchandise exports) of 1964?
Keep it short and to the point. 5.08. What is the difference between the highest and the second highest Exports(as % of merchandise exports) of 1965?
Your response must be concise. 4.68. What is the difference between the highest and the lowest Exports(as % of merchandise exports) in 1962?
Make the answer very short. 91.97. What is the difference between the highest and the lowest Exports(as % of merchandise exports) of 1963?
Your answer should be very brief. 55.56. What is the difference between the highest and the lowest Exports(as % of merchandise exports) of 1964?
Your answer should be compact. 59.16. What is the difference between the highest and the lowest Exports(as % of merchandise exports) in 1965?
Provide a short and direct response. 58.33. 